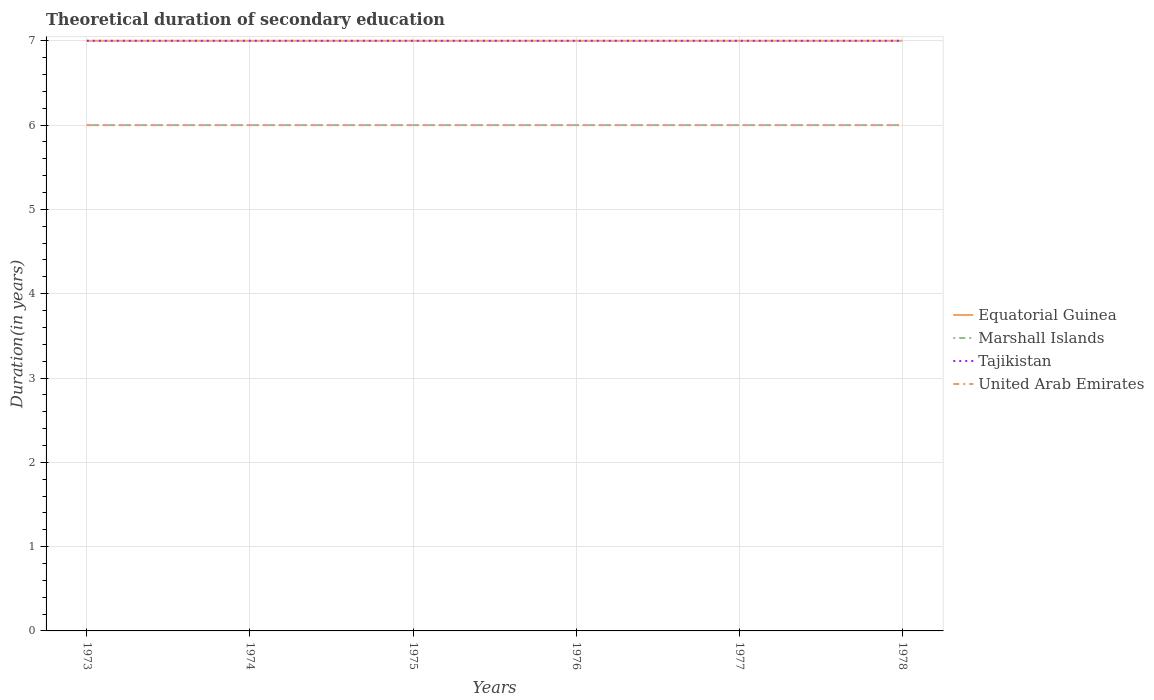How many different coloured lines are there?
Your response must be concise. 4. Is the number of lines equal to the number of legend labels?
Keep it short and to the point. Yes. Across all years, what is the maximum total theoretical duration of secondary education in Marshall Islands?
Keep it short and to the point. 6. In which year was the total theoretical duration of secondary education in Marshall Islands maximum?
Offer a very short reply. 1973. What is the difference between the highest and the second highest total theoretical duration of secondary education in Marshall Islands?
Your response must be concise. 0. What is the difference between the highest and the lowest total theoretical duration of secondary education in Equatorial Guinea?
Provide a succinct answer. 0. How many years are there in the graph?
Your answer should be very brief. 6. Does the graph contain grids?
Your answer should be compact. Yes. Where does the legend appear in the graph?
Provide a short and direct response. Center right. How many legend labels are there?
Keep it short and to the point. 4. How are the legend labels stacked?
Offer a very short reply. Vertical. What is the title of the graph?
Provide a short and direct response. Theoretical duration of secondary education. Does "Least developed countries" appear as one of the legend labels in the graph?
Ensure brevity in your answer.  No. What is the label or title of the Y-axis?
Provide a short and direct response. Duration(in years). What is the Duration(in years) of Equatorial Guinea in 1973?
Give a very brief answer. 7. What is the Duration(in years) in United Arab Emirates in 1973?
Offer a very short reply. 6. What is the Duration(in years) in Marshall Islands in 1974?
Keep it short and to the point. 6. What is the Duration(in years) of United Arab Emirates in 1974?
Provide a succinct answer. 6. What is the Duration(in years) of United Arab Emirates in 1975?
Provide a short and direct response. 6. What is the Duration(in years) of Marshall Islands in 1976?
Make the answer very short. 6. What is the Duration(in years) of United Arab Emirates in 1976?
Offer a very short reply. 6. What is the Duration(in years) of Marshall Islands in 1977?
Make the answer very short. 6. What is the Duration(in years) of Tajikistan in 1977?
Offer a terse response. 7. Across all years, what is the maximum Duration(in years) of Tajikistan?
Provide a short and direct response. 7. Across all years, what is the minimum Duration(in years) in Tajikistan?
Provide a short and direct response. 7. Across all years, what is the minimum Duration(in years) in United Arab Emirates?
Offer a terse response. 6. What is the total Duration(in years) in Equatorial Guinea in the graph?
Your response must be concise. 42. What is the difference between the Duration(in years) of Tajikistan in 1973 and that in 1975?
Ensure brevity in your answer.  0. What is the difference between the Duration(in years) in United Arab Emirates in 1973 and that in 1975?
Your response must be concise. 0. What is the difference between the Duration(in years) in Equatorial Guinea in 1973 and that in 1976?
Make the answer very short. 0. What is the difference between the Duration(in years) of Marshall Islands in 1973 and that in 1976?
Give a very brief answer. 0. What is the difference between the Duration(in years) in Tajikistan in 1973 and that in 1977?
Keep it short and to the point. 0. What is the difference between the Duration(in years) in United Arab Emirates in 1973 and that in 1977?
Your answer should be compact. 0. What is the difference between the Duration(in years) of Equatorial Guinea in 1973 and that in 1978?
Keep it short and to the point. 0. What is the difference between the Duration(in years) in Marshall Islands in 1973 and that in 1978?
Your answer should be compact. 0. What is the difference between the Duration(in years) of United Arab Emirates in 1974 and that in 1975?
Offer a terse response. 0. What is the difference between the Duration(in years) of Equatorial Guinea in 1974 and that in 1976?
Offer a very short reply. 0. What is the difference between the Duration(in years) in Marshall Islands in 1974 and that in 1976?
Your answer should be compact. 0. What is the difference between the Duration(in years) of United Arab Emirates in 1974 and that in 1976?
Your answer should be very brief. 0. What is the difference between the Duration(in years) in Equatorial Guinea in 1974 and that in 1977?
Provide a short and direct response. 0. What is the difference between the Duration(in years) of Tajikistan in 1974 and that in 1977?
Make the answer very short. 0. What is the difference between the Duration(in years) in Marshall Islands in 1974 and that in 1978?
Provide a short and direct response. 0. What is the difference between the Duration(in years) in United Arab Emirates in 1974 and that in 1978?
Keep it short and to the point. 0. What is the difference between the Duration(in years) of Equatorial Guinea in 1975 and that in 1976?
Ensure brevity in your answer.  0. What is the difference between the Duration(in years) of Tajikistan in 1975 and that in 1976?
Offer a very short reply. 0. What is the difference between the Duration(in years) of United Arab Emirates in 1975 and that in 1976?
Your answer should be compact. 0. What is the difference between the Duration(in years) of Marshall Islands in 1975 and that in 1977?
Give a very brief answer. 0. What is the difference between the Duration(in years) in Tajikistan in 1975 and that in 1977?
Offer a very short reply. 0. What is the difference between the Duration(in years) in Marshall Islands in 1975 and that in 1978?
Make the answer very short. 0. What is the difference between the Duration(in years) of Tajikistan in 1975 and that in 1978?
Keep it short and to the point. 0. What is the difference between the Duration(in years) of Equatorial Guinea in 1976 and that in 1977?
Your answer should be very brief. 0. What is the difference between the Duration(in years) in Marshall Islands in 1976 and that in 1977?
Your answer should be compact. 0. What is the difference between the Duration(in years) of United Arab Emirates in 1976 and that in 1977?
Your answer should be very brief. 0. What is the difference between the Duration(in years) in Marshall Islands in 1976 and that in 1978?
Make the answer very short. 0. What is the difference between the Duration(in years) of Tajikistan in 1976 and that in 1978?
Your answer should be compact. 0. What is the difference between the Duration(in years) of Equatorial Guinea in 1977 and that in 1978?
Keep it short and to the point. 0. What is the difference between the Duration(in years) in Tajikistan in 1977 and that in 1978?
Your response must be concise. 0. What is the difference between the Duration(in years) in United Arab Emirates in 1977 and that in 1978?
Keep it short and to the point. 0. What is the difference between the Duration(in years) of Equatorial Guinea in 1973 and the Duration(in years) of Marshall Islands in 1974?
Provide a short and direct response. 1. What is the difference between the Duration(in years) of Equatorial Guinea in 1973 and the Duration(in years) of United Arab Emirates in 1974?
Your answer should be compact. 1. What is the difference between the Duration(in years) in Tajikistan in 1973 and the Duration(in years) in United Arab Emirates in 1974?
Your answer should be very brief. 1. What is the difference between the Duration(in years) of Marshall Islands in 1973 and the Duration(in years) of United Arab Emirates in 1975?
Make the answer very short. 0. What is the difference between the Duration(in years) in Equatorial Guinea in 1973 and the Duration(in years) in Marshall Islands in 1976?
Your answer should be very brief. 1. What is the difference between the Duration(in years) of Marshall Islands in 1973 and the Duration(in years) of Tajikistan in 1976?
Offer a very short reply. -1. What is the difference between the Duration(in years) of Marshall Islands in 1973 and the Duration(in years) of United Arab Emirates in 1976?
Your answer should be compact. 0. What is the difference between the Duration(in years) of Equatorial Guinea in 1973 and the Duration(in years) of Tajikistan in 1977?
Make the answer very short. 0. What is the difference between the Duration(in years) in Equatorial Guinea in 1973 and the Duration(in years) in United Arab Emirates in 1977?
Your response must be concise. 1. What is the difference between the Duration(in years) in Marshall Islands in 1973 and the Duration(in years) in United Arab Emirates in 1977?
Keep it short and to the point. 0. What is the difference between the Duration(in years) of Tajikistan in 1973 and the Duration(in years) of United Arab Emirates in 1977?
Offer a terse response. 1. What is the difference between the Duration(in years) of Equatorial Guinea in 1973 and the Duration(in years) of Tajikistan in 1978?
Your answer should be compact. 0. What is the difference between the Duration(in years) in Marshall Islands in 1973 and the Duration(in years) in Tajikistan in 1978?
Give a very brief answer. -1. What is the difference between the Duration(in years) in Equatorial Guinea in 1974 and the Duration(in years) in Marshall Islands in 1975?
Keep it short and to the point. 1. What is the difference between the Duration(in years) of Equatorial Guinea in 1974 and the Duration(in years) of United Arab Emirates in 1975?
Offer a very short reply. 1. What is the difference between the Duration(in years) of Marshall Islands in 1974 and the Duration(in years) of Tajikistan in 1975?
Your answer should be compact. -1. What is the difference between the Duration(in years) of Marshall Islands in 1974 and the Duration(in years) of United Arab Emirates in 1975?
Your answer should be compact. 0. What is the difference between the Duration(in years) in Equatorial Guinea in 1974 and the Duration(in years) in Marshall Islands in 1976?
Your answer should be very brief. 1. What is the difference between the Duration(in years) in Equatorial Guinea in 1974 and the Duration(in years) in Tajikistan in 1976?
Make the answer very short. 0. What is the difference between the Duration(in years) in Marshall Islands in 1974 and the Duration(in years) in Tajikistan in 1976?
Offer a terse response. -1. What is the difference between the Duration(in years) of Tajikistan in 1974 and the Duration(in years) of United Arab Emirates in 1976?
Make the answer very short. 1. What is the difference between the Duration(in years) of Equatorial Guinea in 1974 and the Duration(in years) of United Arab Emirates in 1977?
Provide a succinct answer. 1. What is the difference between the Duration(in years) of Marshall Islands in 1974 and the Duration(in years) of Tajikistan in 1978?
Make the answer very short. -1. What is the difference between the Duration(in years) in Equatorial Guinea in 1975 and the Duration(in years) in Tajikistan in 1976?
Give a very brief answer. 0. What is the difference between the Duration(in years) of Equatorial Guinea in 1975 and the Duration(in years) of United Arab Emirates in 1976?
Keep it short and to the point. 1. What is the difference between the Duration(in years) of Marshall Islands in 1975 and the Duration(in years) of Tajikistan in 1976?
Provide a short and direct response. -1. What is the difference between the Duration(in years) in Marshall Islands in 1975 and the Duration(in years) in United Arab Emirates in 1976?
Keep it short and to the point. 0. What is the difference between the Duration(in years) of Equatorial Guinea in 1975 and the Duration(in years) of Marshall Islands in 1977?
Offer a terse response. 1. What is the difference between the Duration(in years) in Marshall Islands in 1975 and the Duration(in years) in United Arab Emirates in 1977?
Give a very brief answer. 0. What is the difference between the Duration(in years) of Tajikistan in 1975 and the Duration(in years) of United Arab Emirates in 1977?
Keep it short and to the point. 1. What is the difference between the Duration(in years) of Equatorial Guinea in 1975 and the Duration(in years) of Tajikistan in 1978?
Make the answer very short. 0. What is the difference between the Duration(in years) in Marshall Islands in 1975 and the Duration(in years) in Tajikistan in 1978?
Make the answer very short. -1. What is the difference between the Duration(in years) in Equatorial Guinea in 1976 and the Duration(in years) in Marshall Islands in 1977?
Your response must be concise. 1. What is the difference between the Duration(in years) of Equatorial Guinea in 1976 and the Duration(in years) of Tajikistan in 1977?
Ensure brevity in your answer.  0. What is the difference between the Duration(in years) in Equatorial Guinea in 1976 and the Duration(in years) in United Arab Emirates in 1977?
Give a very brief answer. 1. What is the difference between the Duration(in years) in Equatorial Guinea in 1976 and the Duration(in years) in Tajikistan in 1978?
Your response must be concise. 0. What is the difference between the Duration(in years) in Marshall Islands in 1976 and the Duration(in years) in Tajikistan in 1978?
Keep it short and to the point. -1. What is the difference between the Duration(in years) in Tajikistan in 1976 and the Duration(in years) in United Arab Emirates in 1978?
Give a very brief answer. 1. What is the difference between the Duration(in years) of Equatorial Guinea in 1977 and the Duration(in years) of Marshall Islands in 1978?
Offer a very short reply. 1. What is the difference between the Duration(in years) in Equatorial Guinea in 1977 and the Duration(in years) in Tajikistan in 1978?
Offer a terse response. 0. What is the difference between the Duration(in years) in Marshall Islands in 1977 and the Duration(in years) in Tajikistan in 1978?
Make the answer very short. -1. What is the difference between the Duration(in years) of Marshall Islands in 1977 and the Duration(in years) of United Arab Emirates in 1978?
Your answer should be compact. 0. What is the difference between the Duration(in years) of Tajikistan in 1977 and the Duration(in years) of United Arab Emirates in 1978?
Your response must be concise. 1. What is the average Duration(in years) of Tajikistan per year?
Make the answer very short. 7. What is the average Duration(in years) in United Arab Emirates per year?
Make the answer very short. 6. In the year 1973, what is the difference between the Duration(in years) of Equatorial Guinea and Duration(in years) of Marshall Islands?
Keep it short and to the point. 1. In the year 1973, what is the difference between the Duration(in years) of Tajikistan and Duration(in years) of United Arab Emirates?
Make the answer very short. 1. In the year 1974, what is the difference between the Duration(in years) of Equatorial Guinea and Duration(in years) of Marshall Islands?
Make the answer very short. 1. In the year 1974, what is the difference between the Duration(in years) in Equatorial Guinea and Duration(in years) in Tajikistan?
Provide a short and direct response. 0. In the year 1974, what is the difference between the Duration(in years) of Marshall Islands and Duration(in years) of United Arab Emirates?
Offer a terse response. 0. In the year 1974, what is the difference between the Duration(in years) in Tajikistan and Duration(in years) in United Arab Emirates?
Your answer should be very brief. 1. In the year 1975, what is the difference between the Duration(in years) of Equatorial Guinea and Duration(in years) of Marshall Islands?
Keep it short and to the point. 1. In the year 1975, what is the difference between the Duration(in years) of Equatorial Guinea and Duration(in years) of Tajikistan?
Ensure brevity in your answer.  0. In the year 1976, what is the difference between the Duration(in years) in Equatorial Guinea and Duration(in years) in Tajikistan?
Provide a short and direct response. 0. In the year 1976, what is the difference between the Duration(in years) in Marshall Islands and Duration(in years) in United Arab Emirates?
Ensure brevity in your answer.  0. In the year 1977, what is the difference between the Duration(in years) of Equatorial Guinea and Duration(in years) of Marshall Islands?
Provide a short and direct response. 1. In the year 1977, what is the difference between the Duration(in years) in Equatorial Guinea and Duration(in years) in Tajikistan?
Your answer should be very brief. 0. In the year 1977, what is the difference between the Duration(in years) in Marshall Islands and Duration(in years) in Tajikistan?
Keep it short and to the point. -1. In the year 1977, what is the difference between the Duration(in years) in Marshall Islands and Duration(in years) in United Arab Emirates?
Provide a succinct answer. 0. In the year 1978, what is the difference between the Duration(in years) of Equatorial Guinea and Duration(in years) of Marshall Islands?
Your answer should be compact. 1. In the year 1978, what is the difference between the Duration(in years) of Equatorial Guinea and Duration(in years) of Tajikistan?
Your answer should be compact. 0. In the year 1978, what is the difference between the Duration(in years) in Equatorial Guinea and Duration(in years) in United Arab Emirates?
Provide a short and direct response. 1. In the year 1978, what is the difference between the Duration(in years) of Marshall Islands and Duration(in years) of Tajikistan?
Your response must be concise. -1. What is the ratio of the Duration(in years) in Equatorial Guinea in 1973 to that in 1974?
Keep it short and to the point. 1. What is the ratio of the Duration(in years) in Marshall Islands in 1973 to that in 1974?
Offer a terse response. 1. What is the ratio of the Duration(in years) in Tajikistan in 1973 to that in 1974?
Make the answer very short. 1. What is the ratio of the Duration(in years) of United Arab Emirates in 1973 to that in 1974?
Ensure brevity in your answer.  1. What is the ratio of the Duration(in years) of Equatorial Guinea in 1973 to that in 1975?
Provide a short and direct response. 1. What is the ratio of the Duration(in years) in Marshall Islands in 1973 to that in 1975?
Offer a terse response. 1. What is the ratio of the Duration(in years) of Tajikistan in 1973 to that in 1975?
Keep it short and to the point. 1. What is the ratio of the Duration(in years) of Equatorial Guinea in 1973 to that in 1976?
Offer a very short reply. 1. What is the ratio of the Duration(in years) in Marshall Islands in 1973 to that in 1976?
Give a very brief answer. 1. What is the ratio of the Duration(in years) in Tajikistan in 1973 to that in 1976?
Your answer should be very brief. 1. What is the ratio of the Duration(in years) of Equatorial Guinea in 1973 to that in 1977?
Your response must be concise. 1. What is the ratio of the Duration(in years) of Tajikistan in 1973 to that in 1977?
Your answer should be compact. 1. What is the ratio of the Duration(in years) of Marshall Islands in 1973 to that in 1978?
Provide a short and direct response. 1. What is the ratio of the Duration(in years) of Tajikistan in 1973 to that in 1978?
Your response must be concise. 1. What is the ratio of the Duration(in years) of Marshall Islands in 1974 to that in 1975?
Give a very brief answer. 1. What is the ratio of the Duration(in years) of Equatorial Guinea in 1974 to that in 1976?
Give a very brief answer. 1. What is the ratio of the Duration(in years) of Tajikistan in 1974 to that in 1976?
Your answer should be compact. 1. What is the ratio of the Duration(in years) of Equatorial Guinea in 1974 to that in 1977?
Make the answer very short. 1. What is the ratio of the Duration(in years) in Marshall Islands in 1974 to that in 1977?
Provide a short and direct response. 1. What is the ratio of the Duration(in years) of Tajikistan in 1974 to that in 1977?
Provide a short and direct response. 1. What is the ratio of the Duration(in years) of Equatorial Guinea in 1974 to that in 1978?
Your answer should be very brief. 1. What is the ratio of the Duration(in years) of Tajikistan in 1974 to that in 1978?
Provide a succinct answer. 1. What is the ratio of the Duration(in years) of Equatorial Guinea in 1975 to that in 1976?
Your answer should be compact. 1. What is the ratio of the Duration(in years) of United Arab Emirates in 1975 to that in 1976?
Your answer should be very brief. 1. What is the ratio of the Duration(in years) in Equatorial Guinea in 1975 to that in 1977?
Your response must be concise. 1. What is the ratio of the Duration(in years) in Marshall Islands in 1975 to that in 1977?
Your answer should be compact. 1. What is the ratio of the Duration(in years) in Tajikistan in 1975 to that in 1977?
Keep it short and to the point. 1. What is the ratio of the Duration(in years) in United Arab Emirates in 1975 to that in 1977?
Offer a terse response. 1. What is the ratio of the Duration(in years) in Equatorial Guinea in 1975 to that in 1978?
Make the answer very short. 1. What is the ratio of the Duration(in years) in United Arab Emirates in 1975 to that in 1978?
Provide a short and direct response. 1. What is the ratio of the Duration(in years) of Marshall Islands in 1976 to that in 1977?
Offer a very short reply. 1. What is the ratio of the Duration(in years) of Tajikistan in 1976 to that in 1977?
Offer a very short reply. 1. What is the ratio of the Duration(in years) in United Arab Emirates in 1976 to that in 1977?
Provide a succinct answer. 1. What is the ratio of the Duration(in years) in Equatorial Guinea in 1976 to that in 1978?
Keep it short and to the point. 1. What is the ratio of the Duration(in years) of Marshall Islands in 1976 to that in 1978?
Provide a short and direct response. 1. What is the ratio of the Duration(in years) of Tajikistan in 1976 to that in 1978?
Give a very brief answer. 1. What is the ratio of the Duration(in years) in United Arab Emirates in 1976 to that in 1978?
Provide a short and direct response. 1. What is the ratio of the Duration(in years) of Marshall Islands in 1977 to that in 1978?
Offer a very short reply. 1. What is the ratio of the Duration(in years) in United Arab Emirates in 1977 to that in 1978?
Make the answer very short. 1. What is the difference between the highest and the second highest Duration(in years) of Equatorial Guinea?
Your answer should be compact. 0. What is the difference between the highest and the second highest Duration(in years) in United Arab Emirates?
Give a very brief answer. 0. What is the difference between the highest and the lowest Duration(in years) in Equatorial Guinea?
Your answer should be compact. 0. What is the difference between the highest and the lowest Duration(in years) of Marshall Islands?
Provide a succinct answer. 0. What is the difference between the highest and the lowest Duration(in years) in Tajikistan?
Make the answer very short. 0. 